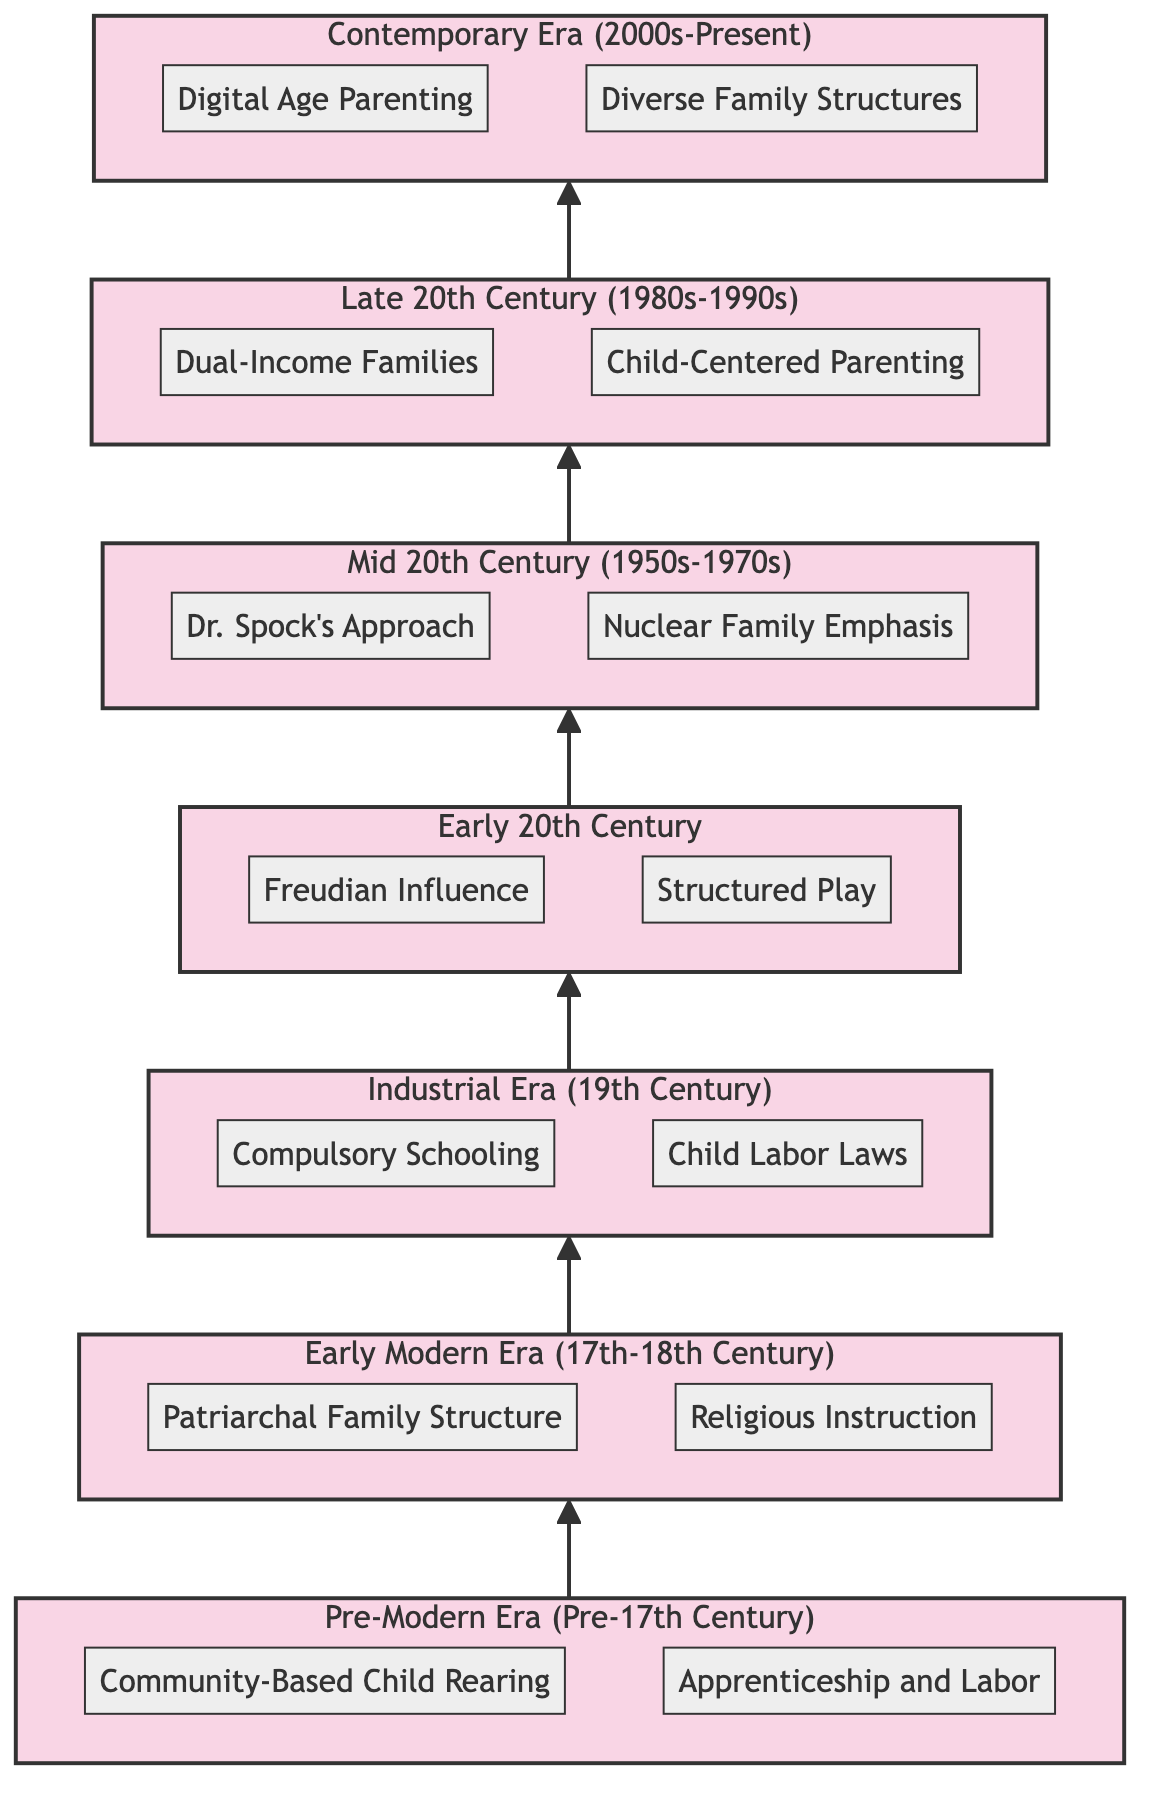What is the time period for the Pre-Modern Era? The diagram explicitly labels the Pre-Modern Era as "Pre-17th Century,” which indicates the time span it covers.
Answer: Pre-17th Century How many practices are listed for the Early Modern Era? By examining the Early Modern Era section, we see two practices clearly defined: "Patriarchal Family Structure" and "Religious Instruction.” Therefore, the count of practices is two.
Answer: 2 What practice is associated with Child Labor Laws? The diagram shows "Child Labor Laws" under the "Industrial Era (19th Century)" section, linking the practice directly to that era.
Answer: Child Labor Laws Which era introduced Dual-Income Families? Looking at the Late 20th Century section, "Dual-Income Families" is specifically listed, indicating it is the era in which this practice emerged.
Answer: Late 20th Century What is the progression of child-rearing practices from the Pre-Modern Era to the Contemporary Era? Starting from the Pre-Modern Era, we see community-based child-rearing evolving into structured educational systems in the Industrial Era, leading to more individualized approaches in the Late 20th Century, culminating in this diverse family structure of the Contemporary Era. This shows an evolutionary trend from collective care to individualized parenting.
Answer: Evolution from community care to individualized parenting How are Diverse Family Structures and Digital Age Parenting linked? Both practices are included in the Contemporary Era section, demonstrating a contemporary focus on addressing modern family dynamics and challenges in upbringing children within the digital landscape, reflecting the interplay of technology and family structure today.
Answer: Linked through Contemporary Era practices What were the primary influences on child-rearing in the Early 20th Century? The section for the Early 20th Century includes "Freudian Influence," which emphasizes psychological impacts, and "Structured Play," promoting developmental activities, highlighting the era's dual focus on psychological and practical child development approaches.
Answer: Psychological and practical influences What significant change did the Industrial Era bring to child-rearing practices? The introduction of "Compulsory Schooling," which mandates education, fundamentally shifted child-rearing practices by prioritizing formal academic environments over labor, signaling the recognition of childhood as a distinct developmental stage needing educational focus.
Answer: Compulsory Schooling What connects the Mid 20th Century practices to the characterization of family structures? The practices "Dr. Spock's Approach" and "Nuclear Family Emphasis" connect through their focus on individualized parenting within a defined family structure, showcasing an emerging trend that emphasizes the personal nurturing of children in the established nuclear family framework.
Answer: Individualized nurturing in a nuclear family framework 